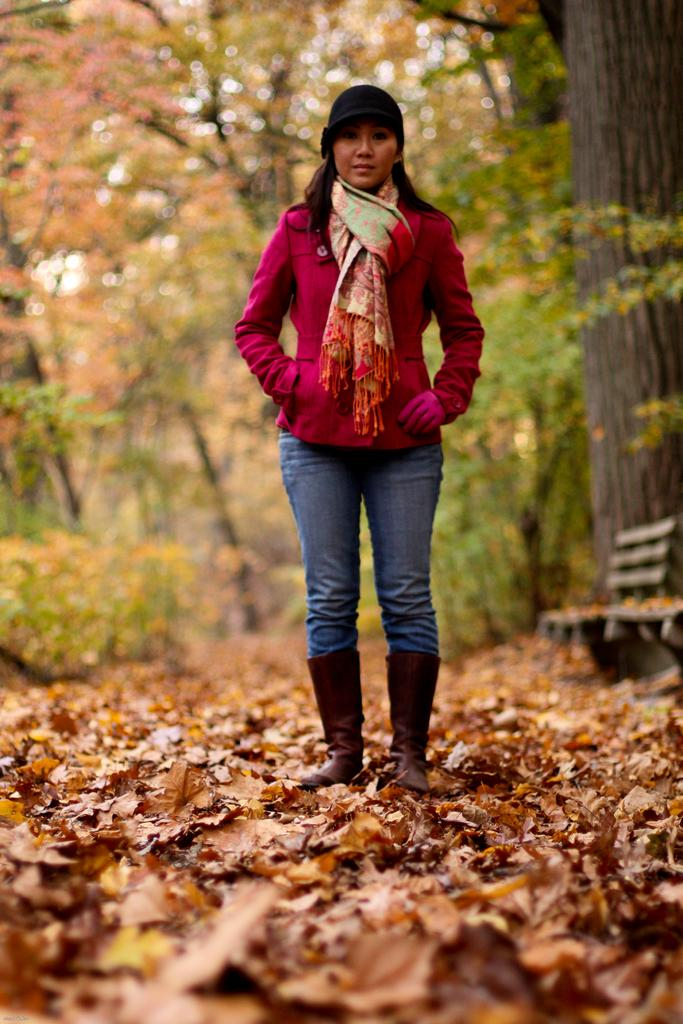What is the main subject of the image? There is a woman standing in the image. What is the woman standing on? The woman is standing on dry leaves. What can be seen in the background of the image? There are trees visible behind the woman. What type of guitar is the woman playing in the image? There is no guitar present in the image; the woman is simply standing on dry leaves with trees visible in the background. 